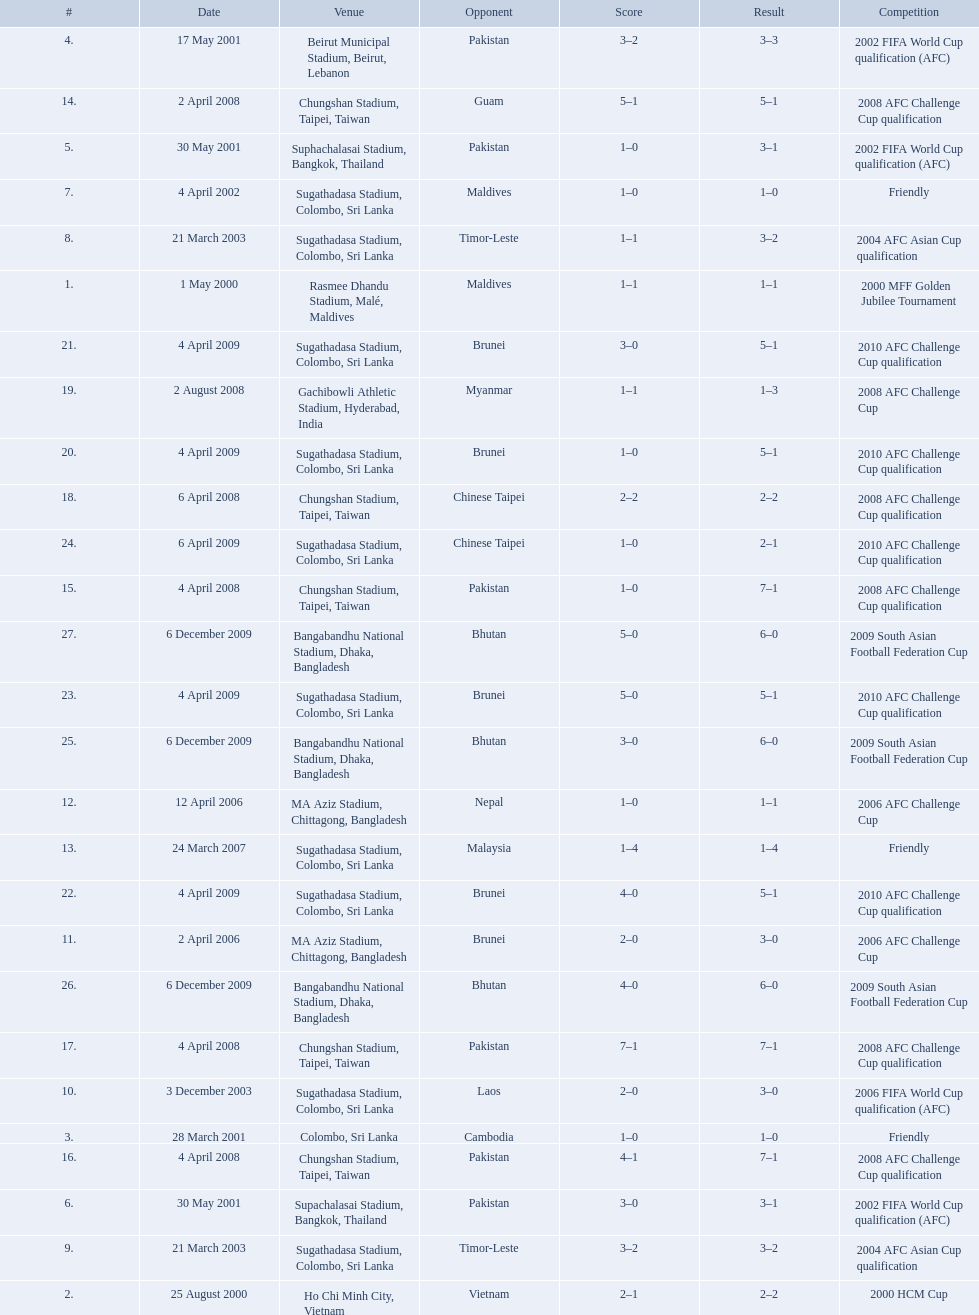What are the venues Rasmee Dhandu Stadium, Malé, Maldives, Ho Chi Minh City, Vietnam, Colombo, Sri Lanka, Beirut Municipal Stadium, Beirut, Lebanon, Suphachalasai Stadium, Bangkok, Thailand, Supachalasai Stadium, Bangkok, Thailand, Sugathadasa Stadium, Colombo, Sri Lanka, Sugathadasa Stadium, Colombo, Sri Lanka, Sugathadasa Stadium, Colombo, Sri Lanka, Sugathadasa Stadium, Colombo, Sri Lanka, MA Aziz Stadium, Chittagong, Bangladesh, MA Aziz Stadium, Chittagong, Bangladesh, Sugathadasa Stadium, Colombo, Sri Lanka, Chungshan Stadium, Taipei, Taiwan, Chungshan Stadium, Taipei, Taiwan, Chungshan Stadium, Taipei, Taiwan, Chungshan Stadium, Taipei, Taiwan, Chungshan Stadium, Taipei, Taiwan, Gachibowli Athletic Stadium, Hyderabad, India, Sugathadasa Stadium, Colombo, Sri Lanka, Sugathadasa Stadium, Colombo, Sri Lanka, Sugathadasa Stadium, Colombo, Sri Lanka, Sugathadasa Stadium, Colombo, Sri Lanka, Sugathadasa Stadium, Colombo, Sri Lanka, Bangabandhu National Stadium, Dhaka, Bangladesh, Bangabandhu National Stadium, Dhaka, Bangladesh, Bangabandhu National Stadium, Dhaka, Bangladesh. What are the #'s? 1., 2., 3., 4., 5., 6., 7., 8., 9., 10., 11., 12., 13., 14., 15., 16., 17., 18., 19., 20., 21., 22., 23., 24., 25., 26., 27. Which one is #1? Rasmee Dhandu Stadium, Malé, Maldives. 